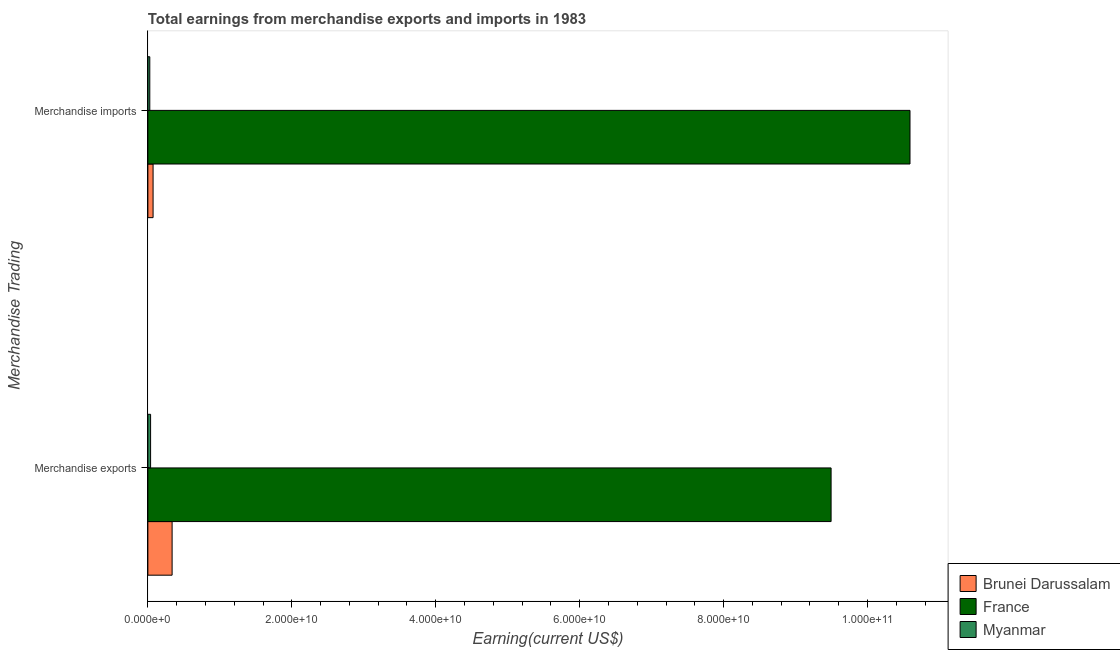How many groups of bars are there?
Give a very brief answer. 2. Are the number of bars on each tick of the Y-axis equal?
Your answer should be very brief. Yes. What is the label of the 2nd group of bars from the top?
Ensure brevity in your answer.  Merchandise exports. What is the earnings from merchandise imports in France?
Provide a short and direct response. 1.06e+11. Across all countries, what is the maximum earnings from merchandise imports?
Give a very brief answer. 1.06e+11. Across all countries, what is the minimum earnings from merchandise exports?
Ensure brevity in your answer.  3.78e+08. In which country was the earnings from merchandise exports maximum?
Provide a short and direct response. France. In which country was the earnings from merchandise exports minimum?
Keep it short and to the point. Myanmar. What is the total earnings from merchandise imports in the graph?
Provide a succinct answer. 1.07e+11. What is the difference between the earnings from merchandise exports in Myanmar and that in Brunei Darussalam?
Your response must be concise. -2.99e+09. What is the difference between the earnings from merchandise exports in Myanmar and the earnings from merchandise imports in France?
Your answer should be compact. -1.06e+11. What is the average earnings from merchandise exports per country?
Provide a short and direct response. 3.29e+1. What is the difference between the earnings from merchandise imports and earnings from merchandise exports in France?
Your answer should be very brief. 1.10e+1. In how many countries, is the earnings from merchandise imports greater than 56000000000 US$?
Ensure brevity in your answer.  1. What is the ratio of the earnings from merchandise exports in France to that in Brunei Darussalam?
Your answer should be very brief. 28.18. Is the earnings from merchandise imports in Myanmar less than that in France?
Your answer should be very brief. Yes. In how many countries, is the earnings from merchandise imports greater than the average earnings from merchandise imports taken over all countries?
Your answer should be compact. 1. What does the 1st bar from the top in Merchandise imports represents?
Ensure brevity in your answer.  Myanmar. Are the values on the major ticks of X-axis written in scientific E-notation?
Provide a short and direct response. Yes. Does the graph contain grids?
Offer a terse response. No. How many legend labels are there?
Your answer should be very brief. 3. How are the legend labels stacked?
Provide a short and direct response. Vertical. What is the title of the graph?
Your answer should be very brief. Total earnings from merchandise exports and imports in 1983. Does "Sierra Leone" appear as one of the legend labels in the graph?
Offer a terse response. No. What is the label or title of the X-axis?
Your answer should be very brief. Earning(current US$). What is the label or title of the Y-axis?
Ensure brevity in your answer.  Merchandise Trading. What is the Earning(current US$) of Brunei Darussalam in Merchandise exports?
Offer a very short reply. 3.37e+09. What is the Earning(current US$) in France in Merchandise exports?
Your answer should be compact. 9.49e+1. What is the Earning(current US$) of Myanmar in Merchandise exports?
Offer a terse response. 3.78e+08. What is the Earning(current US$) of Brunei Darussalam in Merchandise imports?
Your response must be concise. 7.24e+08. What is the Earning(current US$) in France in Merchandise imports?
Provide a short and direct response. 1.06e+11. What is the Earning(current US$) of Myanmar in Merchandise imports?
Provide a succinct answer. 2.68e+08. Across all Merchandise Trading, what is the maximum Earning(current US$) in Brunei Darussalam?
Offer a very short reply. 3.37e+09. Across all Merchandise Trading, what is the maximum Earning(current US$) in France?
Your answer should be compact. 1.06e+11. Across all Merchandise Trading, what is the maximum Earning(current US$) in Myanmar?
Ensure brevity in your answer.  3.78e+08. Across all Merchandise Trading, what is the minimum Earning(current US$) of Brunei Darussalam?
Provide a short and direct response. 7.24e+08. Across all Merchandise Trading, what is the minimum Earning(current US$) in France?
Give a very brief answer. 9.49e+1. Across all Merchandise Trading, what is the minimum Earning(current US$) in Myanmar?
Your answer should be compact. 2.68e+08. What is the total Earning(current US$) in Brunei Darussalam in the graph?
Your answer should be very brief. 4.09e+09. What is the total Earning(current US$) in France in the graph?
Give a very brief answer. 2.01e+11. What is the total Earning(current US$) of Myanmar in the graph?
Give a very brief answer. 6.46e+08. What is the difference between the Earning(current US$) of Brunei Darussalam in Merchandise exports and that in Merchandise imports?
Provide a succinct answer. 2.64e+09. What is the difference between the Earning(current US$) of France in Merchandise exports and that in Merchandise imports?
Offer a terse response. -1.10e+1. What is the difference between the Earning(current US$) of Myanmar in Merchandise exports and that in Merchandise imports?
Offer a very short reply. 1.10e+08. What is the difference between the Earning(current US$) in Brunei Darussalam in Merchandise exports and the Earning(current US$) in France in Merchandise imports?
Provide a short and direct response. -1.03e+11. What is the difference between the Earning(current US$) in Brunei Darussalam in Merchandise exports and the Earning(current US$) in Myanmar in Merchandise imports?
Make the answer very short. 3.10e+09. What is the difference between the Earning(current US$) in France in Merchandise exports and the Earning(current US$) in Myanmar in Merchandise imports?
Keep it short and to the point. 9.47e+1. What is the average Earning(current US$) in Brunei Darussalam per Merchandise Trading?
Your answer should be compact. 2.05e+09. What is the average Earning(current US$) in France per Merchandise Trading?
Provide a succinct answer. 1.00e+11. What is the average Earning(current US$) in Myanmar per Merchandise Trading?
Offer a terse response. 3.23e+08. What is the difference between the Earning(current US$) of Brunei Darussalam and Earning(current US$) of France in Merchandise exports?
Keep it short and to the point. -9.16e+1. What is the difference between the Earning(current US$) of Brunei Darussalam and Earning(current US$) of Myanmar in Merchandise exports?
Offer a very short reply. 2.99e+09. What is the difference between the Earning(current US$) of France and Earning(current US$) of Myanmar in Merchandise exports?
Your response must be concise. 9.46e+1. What is the difference between the Earning(current US$) of Brunei Darussalam and Earning(current US$) of France in Merchandise imports?
Your response must be concise. -1.05e+11. What is the difference between the Earning(current US$) in Brunei Darussalam and Earning(current US$) in Myanmar in Merchandise imports?
Your answer should be very brief. 4.56e+08. What is the difference between the Earning(current US$) in France and Earning(current US$) in Myanmar in Merchandise imports?
Ensure brevity in your answer.  1.06e+11. What is the ratio of the Earning(current US$) in Brunei Darussalam in Merchandise exports to that in Merchandise imports?
Provide a short and direct response. 4.65. What is the ratio of the Earning(current US$) of France in Merchandise exports to that in Merchandise imports?
Offer a very short reply. 0.9. What is the ratio of the Earning(current US$) of Myanmar in Merchandise exports to that in Merchandise imports?
Give a very brief answer. 1.41. What is the difference between the highest and the second highest Earning(current US$) of Brunei Darussalam?
Ensure brevity in your answer.  2.64e+09. What is the difference between the highest and the second highest Earning(current US$) in France?
Provide a short and direct response. 1.10e+1. What is the difference between the highest and the second highest Earning(current US$) in Myanmar?
Provide a short and direct response. 1.10e+08. What is the difference between the highest and the lowest Earning(current US$) of Brunei Darussalam?
Give a very brief answer. 2.64e+09. What is the difference between the highest and the lowest Earning(current US$) of France?
Give a very brief answer. 1.10e+1. What is the difference between the highest and the lowest Earning(current US$) in Myanmar?
Keep it short and to the point. 1.10e+08. 